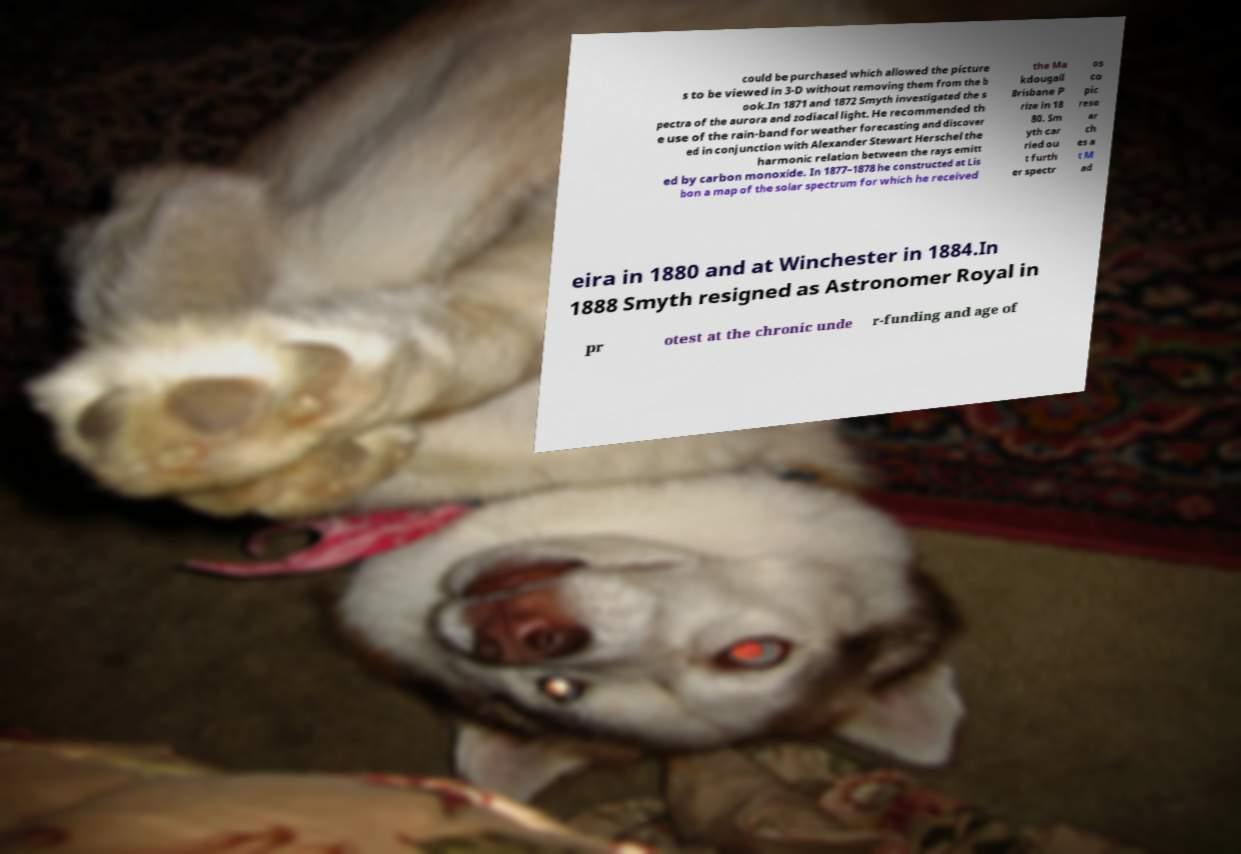Can you accurately transcribe the text from the provided image for me? could be purchased which allowed the picture s to be viewed in 3-D without removing them from the b ook.In 1871 and 1872 Smyth investigated the s pectra of the aurora and zodiacal light. He recommended th e use of the rain-band for weather forecasting and discover ed in conjunction with Alexander Stewart Herschel the harmonic relation between the rays emitt ed by carbon monoxide. In 1877–1878 he constructed at Lis bon a map of the solar spectrum for which he received the Ma kdougall Brisbane P rize in 18 80. Sm yth car ried ou t furth er spectr os co pic rese ar ch es a t M ad eira in 1880 and at Winchester in 1884.In 1888 Smyth resigned as Astronomer Royal in pr otest at the chronic unde r-funding and age of 